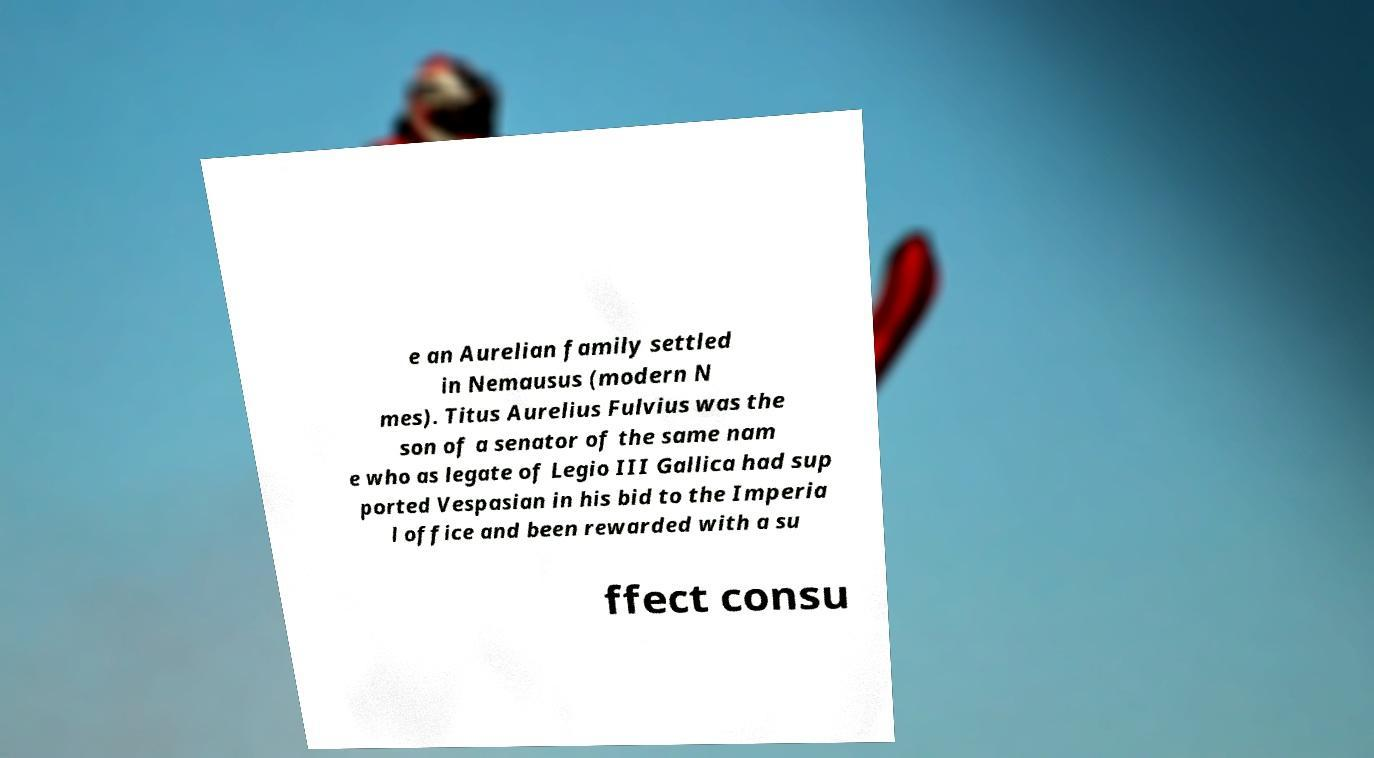I need the written content from this picture converted into text. Can you do that? e an Aurelian family settled in Nemausus (modern N mes). Titus Aurelius Fulvius was the son of a senator of the same nam e who as legate of Legio III Gallica had sup ported Vespasian in his bid to the Imperia l office and been rewarded with a su ffect consu 